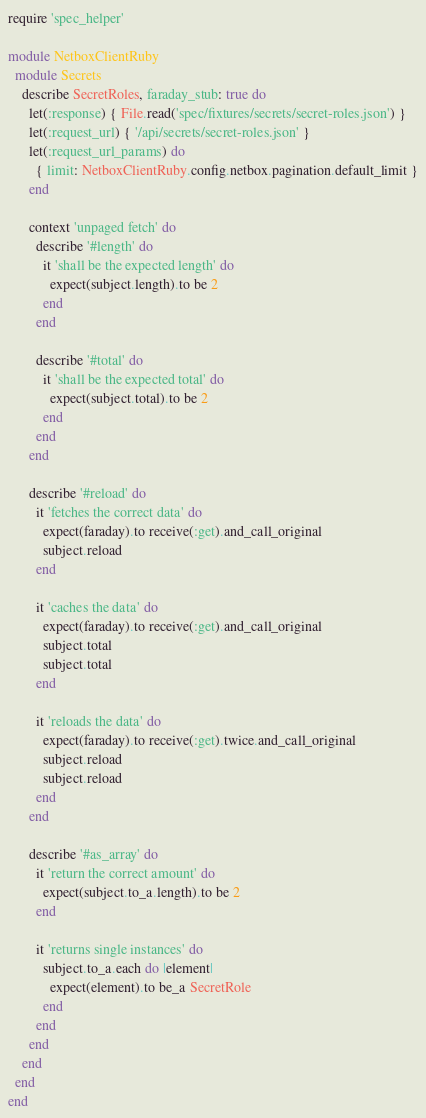Convert code to text. <code><loc_0><loc_0><loc_500><loc_500><_Ruby_>require 'spec_helper'

module NetboxClientRuby
  module Secrets
    describe SecretRoles, faraday_stub: true do
      let(:response) { File.read('spec/fixtures/secrets/secret-roles.json') }
      let(:request_url) { '/api/secrets/secret-roles.json' }
      let(:request_url_params) do
        { limit: NetboxClientRuby.config.netbox.pagination.default_limit }
      end

      context 'unpaged fetch' do
        describe '#length' do
          it 'shall be the expected length' do
            expect(subject.length).to be 2
          end
        end

        describe '#total' do
          it 'shall be the expected total' do
            expect(subject.total).to be 2
          end
        end
      end

      describe '#reload' do
        it 'fetches the correct data' do
          expect(faraday).to receive(:get).and_call_original
          subject.reload
        end

        it 'caches the data' do
          expect(faraday).to receive(:get).and_call_original
          subject.total
          subject.total
        end

        it 'reloads the data' do
          expect(faraday).to receive(:get).twice.and_call_original
          subject.reload
          subject.reload
        end
      end

      describe '#as_array' do
        it 'return the correct amount' do
          expect(subject.to_a.length).to be 2
        end

        it 'returns single instances' do
          subject.to_a.each do |element|
            expect(element).to be_a SecretRole
          end
        end
      end
    end
  end
end
</code> 